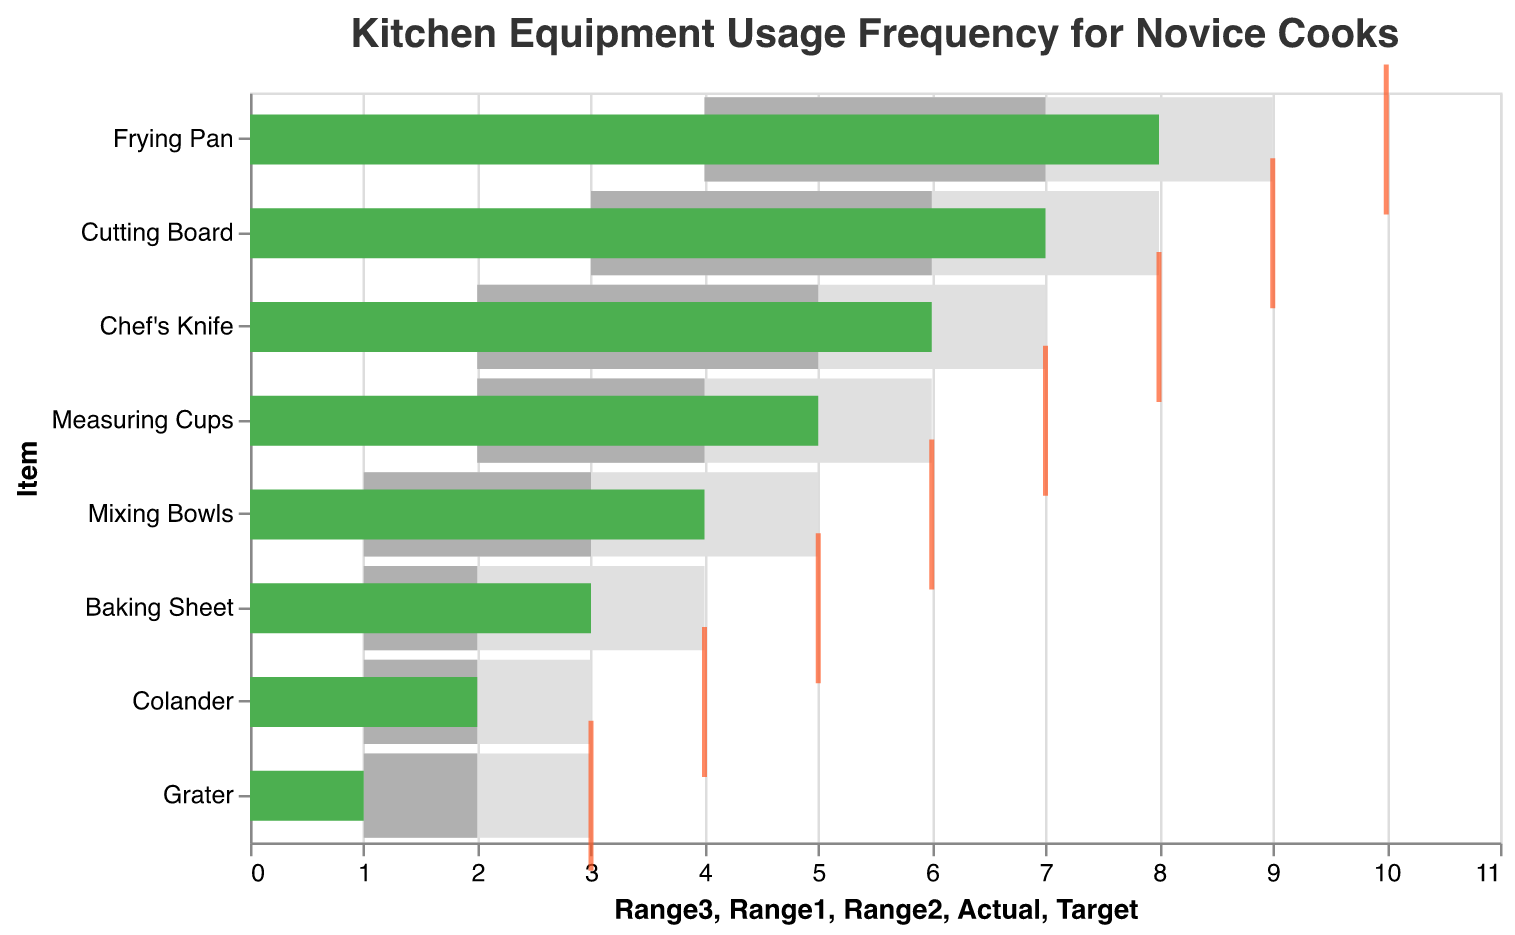What is the most frequently used kitchen equipment according to the chart? The chart lists the frequency of use from most used to least used, with the Frying Pan having the highest 'Actual' value of 8.
Answer: Frying Pan What is the target usage frequency for the Chef's Knife? The target usage frequency is depicted by the red tick mark on each bar. For the Chef's Knife, this tick is at 8.
Answer: 8 Which kitchen equipment has an actual usage frequency of 4? Looking at the green bars representing the 'Actual' value, the Mixing Bowls have an actual usage frequency of 4.
Answer: Mixing Bowls How many pieces of kitchen equipment have an actual usage frequency below their target? Comparing the green bars (Actual) with the red tick marks (Target), all the equipment in the chart have actual usage frequencies below their targets. There are 8 such items.
Answer: 8 What is the range of usage frequency for the Colander in terms of the most optimistic (Range3) estimate? The most optimistic estimate (Range3) for the Colander is shown by the grey-colored range which ends at 3.
Answer: 3 Which kitchen equipment is closest to meeting its target usage frequency? The closest to meeting the target is the Frying Pan, with an actual usage of 8 out of a target of 10, having a difference of 2.
Answer: Frying Pan What is the difference between the actual and target usage frequency of the Measuring Cups? The 'Actual' usage frequency of the Measuring Cups is 5, and the 'Target' is 7. The difference is 7 - 5 = 2.
Answer: 2 How many kitchen tools have an actual usage frequency within their ideal range (Range3)? The ideal range or Range3 for each equipment is depicted by the largest grey bar. The Frying Pan, Cutting Board, and Chef's Knife have actual uses within their Range3. There are 3 such items.
Answer: 3 What is the least frequently used item according to the chart? The item with the smallest 'Actual' value (green bar) is the Grater, with a value of 1.
Answer: Grater 